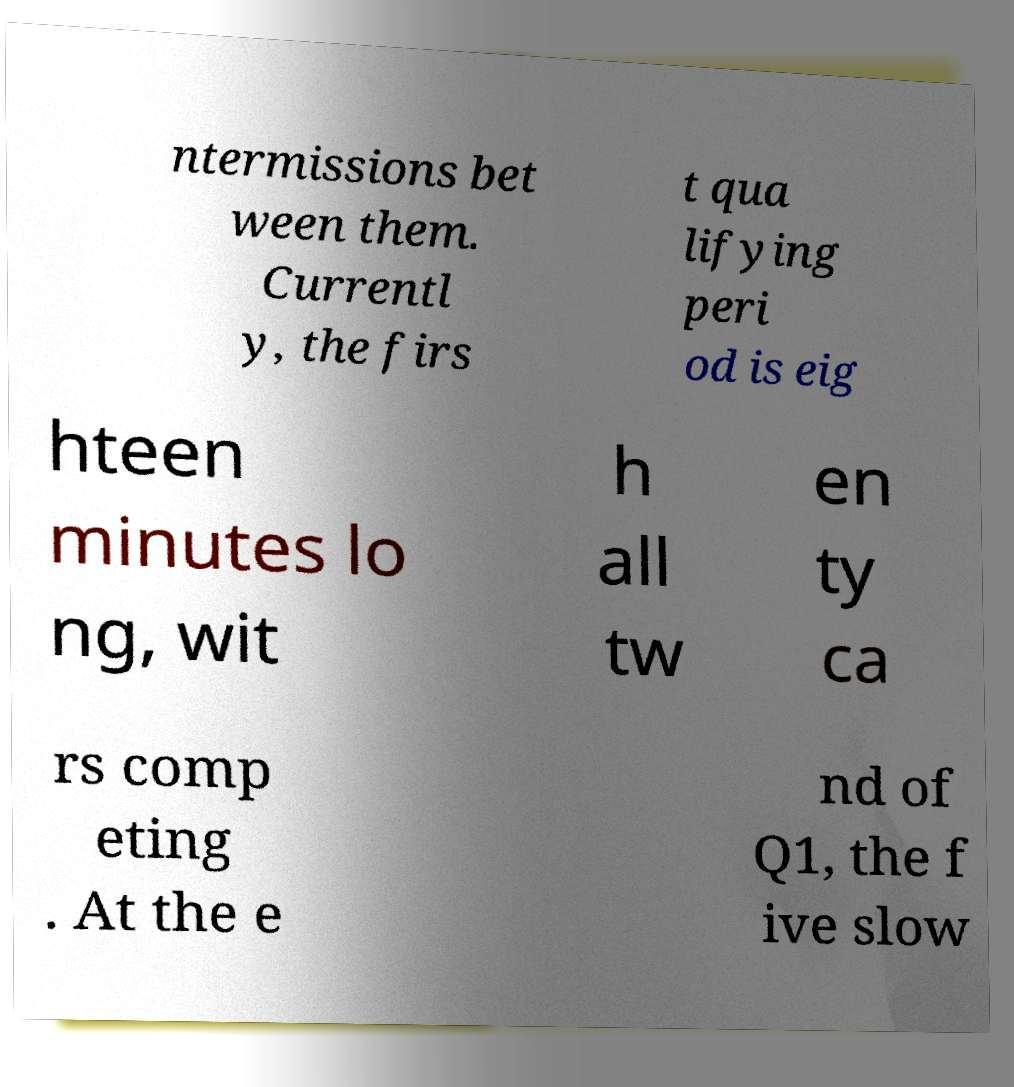Can you read and provide the text displayed in the image?This photo seems to have some interesting text. Can you extract and type it out for me? ntermissions bet ween them. Currentl y, the firs t qua lifying peri od is eig hteen minutes lo ng, wit h all tw en ty ca rs comp eting . At the e nd of Q1, the f ive slow 